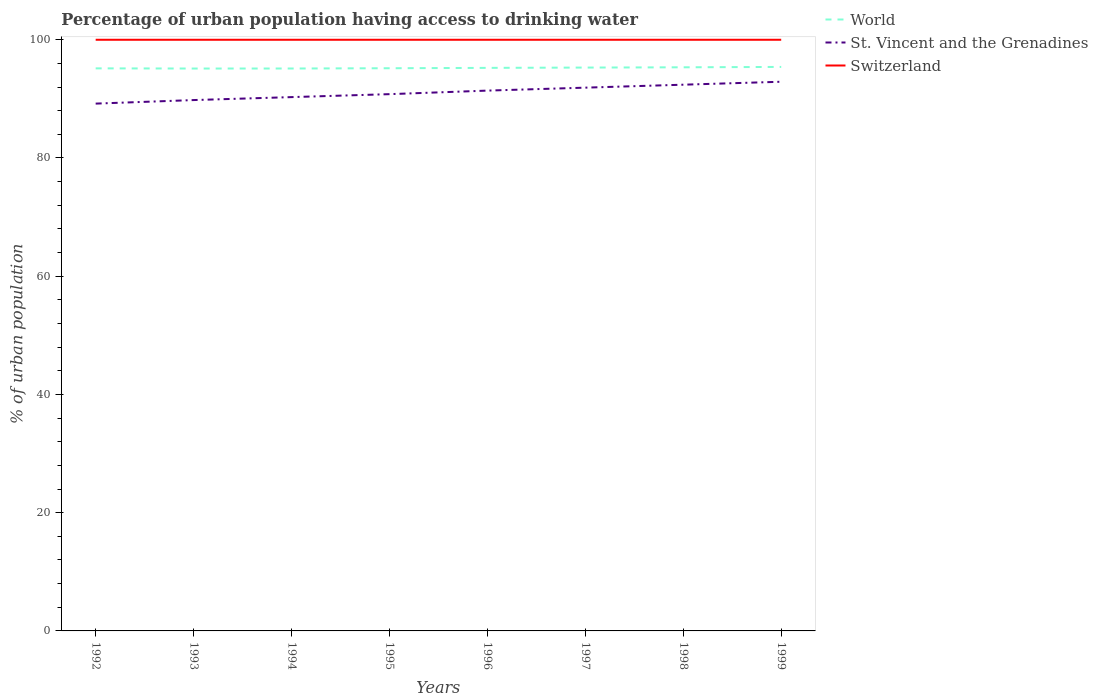How many different coloured lines are there?
Your response must be concise. 3. Is the number of lines equal to the number of legend labels?
Offer a very short reply. Yes. Across all years, what is the maximum percentage of urban population having access to drinking water in World?
Give a very brief answer. 95.13. What is the difference between the highest and the second highest percentage of urban population having access to drinking water in Switzerland?
Provide a short and direct response. 0. What is the difference between the highest and the lowest percentage of urban population having access to drinking water in St. Vincent and the Grenadines?
Ensure brevity in your answer.  4. How many lines are there?
Provide a succinct answer. 3. How many years are there in the graph?
Offer a very short reply. 8. What is the difference between two consecutive major ticks on the Y-axis?
Give a very brief answer. 20. Are the values on the major ticks of Y-axis written in scientific E-notation?
Make the answer very short. No. Does the graph contain any zero values?
Give a very brief answer. No. Does the graph contain grids?
Your response must be concise. No. How are the legend labels stacked?
Offer a terse response. Vertical. What is the title of the graph?
Offer a terse response. Percentage of urban population having access to drinking water. Does "Liberia" appear as one of the legend labels in the graph?
Give a very brief answer. No. What is the label or title of the X-axis?
Ensure brevity in your answer.  Years. What is the label or title of the Y-axis?
Offer a very short reply. % of urban population. What is the % of urban population of World in 1992?
Offer a terse response. 95.16. What is the % of urban population in St. Vincent and the Grenadines in 1992?
Your answer should be compact. 89.2. What is the % of urban population of World in 1993?
Keep it short and to the point. 95.13. What is the % of urban population of St. Vincent and the Grenadines in 1993?
Keep it short and to the point. 89.8. What is the % of urban population of Switzerland in 1993?
Provide a succinct answer. 100. What is the % of urban population of World in 1994?
Provide a short and direct response. 95.14. What is the % of urban population in St. Vincent and the Grenadines in 1994?
Ensure brevity in your answer.  90.3. What is the % of urban population of Switzerland in 1994?
Make the answer very short. 100. What is the % of urban population of World in 1995?
Offer a terse response. 95.18. What is the % of urban population of St. Vincent and the Grenadines in 1995?
Your response must be concise. 90.8. What is the % of urban population in World in 1996?
Provide a succinct answer. 95.25. What is the % of urban population of St. Vincent and the Grenadines in 1996?
Give a very brief answer. 91.4. What is the % of urban population of Switzerland in 1996?
Provide a succinct answer. 100. What is the % of urban population in World in 1997?
Your answer should be compact. 95.3. What is the % of urban population in St. Vincent and the Grenadines in 1997?
Your response must be concise. 91.9. What is the % of urban population in World in 1998?
Your answer should be very brief. 95.34. What is the % of urban population of St. Vincent and the Grenadines in 1998?
Make the answer very short. 92.4. What is the % of urban population of Switzerland in 1998?
Give a very brief answer. 100. What is the % of urban population in World in 1999?
Make the answer very short. 95.41. What is the % of urban population in St. Vincent and the Grenadines in 1999?
Offer a terse response. 92.9. What is the % of urban population of Switzerland in 1999?
Offer a terse response. 100. Across all years, what is the maximum % of urban population in World?
Ensure brevity in your answer.  95.41. Across all years, what is the maximum % of urban population of St. Vincent and the Grenadines?
Your answer should be very brief. 92.9. Across all years, what is the minimum % of urban population of World?
Your response must be concise. 95.13. Across all years, what is the minimum % of urban population of St. Vincent and the Grenadines?
Make the answer very short. 89.2. What is the total % of urban population of World in the graph?
Keep it short and to the point. 761.91. What is the total % of urban population in St. Vincent and the Grenadines in the graph?
Offer a terse response. 728.7. What is the total % of urban population in Switzerland in the graph?
Your response must be concise. 800. What is the difference between the % of urban population in World in 1992 and that in 1993?
Offer a very short reply. 0.03. What is the difference between the % of urban population of St. Vincent and the Grenadines in 1992 and that in 1993?
Offer a very short reply. -0.6. What is the difference between the % of urban population in Switzerland in 1992 and that in 1993?
Provide a short and direct response. 0. What is the difference between the % of urban population in World in 1992 and that in 1994?
Provide a succinct answer. 0.02. What is the difference between the % of urban population of Switzerland in 1992 and that in 1994?
Keep it short and to the point. 0. What is the difference between the % of urban population of World in 1992 and that in 1995?
Your answer should be very brief. -0.02. What is the difference between the % of urban population in World in 1992 and that in 1996?
Give a very brief answer. -0.08. What is the difference between the % of urban population of Switzerland in 1992 and that in 1996?
Your response must be concise. 0. What is the difference between the % of urban population in World in 1992 and that in 1997?
Your response must be concise. -0.13. What is the difference between the % of urban population in St. Vincent and the Grenadines in 1992 and that in 1997?
Give a very brief answer. -2.7. What is the difference between the % of urban population of World in 1992 and that in 1998?
Your answer should be compact. -0.18. What is the difference between the % of urban population of World in 1992 and that in 1999?
Give a very brief answer. -0.24. What is the difference between the % of urban population of St. Vincent and the Grenadines in 1992 and that in 1999?
Provide a short and direct response. -3.7. What is the difference between the % of urban population of World in 1993 and that in 1994?
Give a very brief answer. -0.01. What is the difference between the % of urban population in St. Vincent and the Grenadines in 1993 and that in 1994?
Provide a succinct answer. -0.5. What is the difference between the % of urban population of Switzerland in 1993 and that in 1994?
Keep it short and to the point. 0. What is the difference between the % of urban population in St. Vincent and the Grenadines in 1993 and that in 1995?
Provide a succinct answer. -1. What is the difference between the % of urban population of Switzerland in 1993 and that in 1995?
Keep it short and to the point. 0. What is the difference between the % of urban population in World in 1993 and that in 1996?
Your response must be concise. -0.11. What is the difference between the % of urban population of Switzerland in 1993 and that in 1996?
Offer a terse response. 0. What is the difference between the % of urban population in World in 1993 and that in 1997?
Your answer should be very brief. -0.16. What is the difference between the % of urban population of Switzerland in 1993 and that in 1997?
Offer a terse response. 0. What is the difference between the % of urban population in World in 1993 and that in 1998?
Offer a very short reply. -0.21. What is the difference between the % of urban population of World in 1993 and that in 1999?
Offer a terse response. -0.27. What is the difference between the % of urban population in World in 1994 and that in 1995?
Give a very brief answer. -0.04. What is the difference between the % of urban population in Switzerland in 1994 and that in 1995?
Make the answer very short. 0. What is the difference between the % of urban population in World in 1994 and that in 1996?
Keep it short and to the point. -0.11. What is the difference between the % of urban population of World in 1994 and that in 1997?
Provide a short and direct response. -0.16. What is the difference between the % of urban population of World in 1994 and that in 1998?
Your answer should be compact. -0.2. What is the difference between the % of urban population of St. Vincent and the Grenadines in 1994 and that in 1998?
Ensure brevity in your answer.  -2.1. What is the difference between the % of urban population in World in 1994 and that in 1999?
Provide a short and direct response. -0.27. What is the difference between the % of urban population in World in 1995 and that in 1996?
Your response must be concise. -0.06. What is the difference between the % of urban population in Switzerland in 1995 and that in 1996?
Your answer should be very brief. 0. What is the difference between the % of urban population in World in 1995 and that in 1997?
Your answer should be compact. -0.11. What is the difference between the % of urban population in Switzerland in 1995 and that in 1997?
Offer a very short reply. 0. What is the difference between the % of urban population of World in 1995 and that in 1998?
Make the answer very short. -0.16. What is the difference between the % of urban population of St. Vincent and the Grenadines in 1995 and that in 1998?
Keep it short and to the point. -1.6. What is the difference between the % of urban population in Switzerland in 1995 and that in 1998?
Ensure brevity in your answer.  0. What is the difference between the % of urban population of World in 1995 and that in 1999?
Your answer should be compact. -0.22. What is the difference between the % of urban population in World in 1996 and that in 1997?
Ensure brevity in your answer.  -0.05. What is the difference between the % of urban population of World in 1996 and that in 1998?
Keep it short and to the point. -0.1. What is the difference between the % of urban population in St. Vincent and the Grenadines in 1996 and that in 1998?
Your response must be concise. -1. What is the difference between the % of urban population of World in 1996 and that in 1999?
Your answer should be compact. -0.16. What is the difference between the % of urban population in World in 1997 and that in 1998?
Provide a succinct answer. -0.04. What is the difference between the % of urban population in World in 1997 and that in 1999?
Provide a succinct answer. -0.11. What is the difference between the % of urban population in St. Vincent and the Grenadines in 1997 and that in 1999?
Give a very brief answer. -1. What is the difference between the % of urban population in World in 1998 and that in 1999?
Provide a succinct answer. -0.06. What is the difference between the % of urban population in St. Vincent and the Grenadines in 1998 and that in 1999?
Your response must be concise. -0.5. What is the difference between the % of urban population in World in 1992 and the % of urban population in St. Vincent and the Grenadines in 1993?
Offer a terse response. 5.36. What is the difference between the % of urban population in World in 1992 and the % of urban population in Switzerland in 1993?
Offer a terse response. -4.84. What is the difference between the % of urban population in St. Vincent and the Grenadines in 1992 and the % of urban population in Switzerland in 1993?
Make the answer very short. -10.8. What is the difference between the % of urban population in World in 1992 and the % of urban population in St. Vincent and the Grenadines in 1994?
Your answer should be very brief. 4.86. What is the difference between the % of urban population of World in 1992 and the % of urban population of Switzerland in 1994?
Provide a short and direct response. -4.84. What is the difference between the % of urban population of World in 1992 and the % of urban population of St. Vincent and the Grenadines in 1995?
Offer a very short reply. 4.36. What is the difference between the % of urban population in World in 1992 and the % of urban population in Switzerland in 1995?
Offer a terse response. -4.84. What is the difference between the % of urban population in St. Vincent and the Grenadines in 1992 and the % of urban population in Switzerland in 1995?
Your answer should be compact. -10.8. What is the difference between the % of urban population of World in 1992 and the % of urban population of St. Vincent and the Grenadines in 1996?
Your response must be concise. 3.76. What is the difference between the % of urban population in World in 1992 and the % of urban population in Switzerland in 1996?
Your response must be concise. -4.84. What is the difference between the % of urban population of St. Vincent and the Grenadines in 1992 and the % of urban population of Switzerland in 1996?
Offer a terse response. -10.8. What is the difference between the % of urban population in World in 1992 and the % of urban population in St. Vincent and the Grenadines in 1997?
Offer a very short reply. 3.26. What is the difference between the % of urban population of World in 1992 and the % of urban population of Switzerland in 1997?
Your response must be concise. -4.84. What is the difference between the % of urban population in World in 1992 and the % of urban population in St. Vincent and the Grenadines in 1998?
Provide a short and direct response. 2.76. What is the difference between the % of urban population of World in 1992 and the % of urban population of Switzerland in 1998?
Provide a succinct answer. -4.84. What is the difference between the % of urban population of St. Vincent and the Grenadines in 1992 and the % of urban population of Switzerland in 1998?
Provide a short and direct response. -10.8. What is the difference between the % of urban population in World in 1992 and the % of urban population in St. Vincent and the Grenadines in 1999?
Offer a terse response. 2.26. What is the difference between the % of urban population in World in 1992 and the % of urban population in Switzerland in 1999?
Your response must be concise. -4.84. What is the difference between the % of urban population of World in 1993 and the % of urban population of St. Vincent and the Grenadines in 1994?
Keep it short and to the point. 4.83. What is the difference between the % of urban population of World in 1993 and the % of urban population of Switzerland in 1994?
Your answer should be compact. -4.87. What is the difference between the % of urban population of World in 1993 and the % of urban population of St. Vincent and the Grenadines in 1995?
Provide a succinct answer. 4.33. What is the difference between the % of urban population in World in 1993 and the % of urban population in Switzerland in 1995?
Provide a short and direct response. -4.87. What is the difference between the % of urban population of St. Vincent and the Grenadines in 1993 and the % of urban population of Switzerland in 1995?
Provide a succinct answer. -10.2. What is the difference between the % of urban population in World in 1993 and the % of urban population in St. Vincent and the Grenadines in 1996?
Your answer should be very brief. 3.73. What is the difference between the % of urban population in World in 1993 and the % of urban population in Switzerland in 1996?
Offer a terse response. -4.87. What is the difference between the % of urban population of World in 1993 and the % of urban population of St. Vincent and the Grenadines in 1997?
Offer a very short reply. 3.23. What is the difference between the % of urban population in World in 1993 and the % of urban population in Switzerland in 1997?
Offer a very short reply. -4.87. What is the difference between the % of urban population of World in 1993 and the % of urban population of St. Vincent and the Grenadines in 1998?
Your answer should be compact. 2.73. What is the difference between the % of urban population in World in 1993 and the % of urban population in Switzerland in 1998?
Offer a terse response. -4.87. What is the difference between the % of urban population in World in 1993 and the % of urban population in St. Vincent and the Grenadines in 1999?
Your answer should be very brief. 2.23. What is the difference between the % of urban population in World in 1993 and the % of urban population in Switzerland in 1999?
Your response must be concise. -4.87. What is the difference between the % of urban population of World in 1994 and the % of urban population of St. Vincent and the Grenadines in 1995?
Your answer should be very brief. 4.34. What is the difference between the % of urban population of World in 1994 and the % of urban population of Switzerland in 1995?
Your answer should be compact. -4.86. What is the difference between the % of urban population of St. Vincent and the Grenadines in 1994 and the % of urban population of Switzerland in 1995?
Your response must be concise. -9.7. What is the difference between the % of urban population in World in 1994 and the % of urban population in St. Vincent and the Grenadines in 1996?
Your response must be concise. 3.74. What is the difference between the % of urban population of World in 1994 and the % of urban population of Switzerland in 1996?
Offer a very short reply. -4.86. What is the difference between the % of urban population in St. Vincent and the Grenadines in 1994 and the % of urban population in Switzerland in 1996?
Provide a short and direct response. -9.7. What is the difference between the % of urban population of World in 1994 and the % of urban population of St. Vincent and the Grenadines in 1997?
Give a very brief answer. 3.24. What is the difference between the % of urban population of World in 1994 and the % of urban population of Switzerland in 1997?
Provide a succinct answer. -4.86. What is the difference between the % of urban population in St. Vincent and the Grenadines in 1994 and the % of urban population in Switzerland in 1997?
Provide a short and direct response. -9.7. What is the difference between the % of urban population of World in 1994 and the % of urban population of St. Vincent and the Grenadines in 1998?
Provide a short and direct response. 2.74. What is the difference between the % of urban population in World in 1994 and the % of urban population in Switzerland in 1998?
Offer a terse response. -4.86. What is the difference between the % of urban population of World in 1994 and the % of urban population of St. Vincent and the Grenadines in 1999?
Make the answer very short. 2.24. What is the difference between the % of urban population of World in 1994 and the % of urban population of Switzerland in 1999?
Offer a terse response. -4.86. What is the difference between the % of urban population in St. Vincent and the Grenadines in 1994 and the % of urban population in Switzerland in 1999?
Make the answer very short. -9.7. What is the difference between the % of urban population in World in 1995 and the % of urban population in St. Vincent and the Grenadines in 1996?
Make the answer very short. 3.78. What is the difference between the % of urban population of World in 1995 and the % of urban population of Switzerland in 1996?
Your answer should be compact. -4.82. What is the difference between the % of urban population in St. Vincent and the Grenadines in 1995 and the % of urban population in Switzerland in 1996?
Provide a short and direct response. -9.2. What is the difference between the % of urban population in World in 1995 and the % of urban population in St. Vincent and the Grenadines in 1997?
Give a very brief answer. 3.28. What is the difference between the % of urban population in World in 1995 and the % of urban population in Switzerland in 1997?
Offer a very short reply. -4.82. What is the difference between the % of urban population in World in 1995 and the % of urban population in St. Vincent and the Grenadines in 1998?
Your answer should be compact. 2.78. What is the difference between the % of urban population in World in 1995 and the % of urban population in Switzerland in 1998?
Provide a succinct answer. -4.82. What is the difference between the % of urban population in St. Vincent and the Grenadines in 1995 and the % of urban population in Switzerland in 1998?
Offer a very short reply. -9.2. What is the difference between the % of urban population in World in 1995 and the % of urban population in St. Vincent and the Grenadines in 1999?
Your answer should be compact. 2.28. What is the difference between the % of urban population of World in 1995 and the % of urban population of Switzerland in 1999?
Keep it short and to the point. -4.82. What is the difference between the % of urban population of St. Vincent and the Grenadines in 1995 and the % of urban population of Switzerland in 1999?
Offer a terse response. -9.2. What is the difference between the % of urban population of World in 1996 and the % of urban population of St. Vincent and the Grenadines in 1997?
Give a very brief answer. 3.35. What is the difference between the % of urban population in World in 1996 and the % of urban population in Switzerland in 1997?
Your answer should be compact. -4.75. What is the difference between the % of urban population of St. Vincent and the Grenadines in 1996 and the % of urban population of Switzerland in 1997?
Provide a succinct answer. -8.6. What is the difference between the % of urban population of World in 1996 and the % of urban population of St. Vincent and the Grenadines in 1998?
Offer a terse response. 2.85. What is the difference between the % of urban population of World in 1996 and the % of urban population of Switzerland in 1998?
Provide a succinct answer. -4.75. What is the difference between the % of urban population in World in 1996 and the % of urban population in St. Vincent and the Grenadines in 1999?
Make the answer very short. 2.35. What is the difference between the % of urban population of World in 1996 and the % of urban population of Switzerland in 1999?
Ensure brevity in your answer.  -4.75. What is the difference between the % of urban population in World in 1997 and the % of urban population in St. Vincent and the Grenadines in 1998?
Your answer should be compact. 2.9. What is the difference between the % of urban population in World in 1997 and the % of urban population in Switzerland in 1998?
Provide a succinct answer. -4.7. What is the difference between the % of urban population in St. Vincent and the Grenadines in 1997 and the % of urban population in Switzerland in 1998?
Give a very brief answer. -8.1. What is the difference between the % of urban population of World in 1997 and the % of urban population of St. Vincent and the Grenadines in 1999?
Your answer should be very brief. 2.4. What is the difference between the % of urban population of World in 1997 and the % of urban population of Switzerland in 1999?
Provide a succinct answer. -4.7. What is the difference between the % of urban population in World in 1998 and the % of urban population in St. Vincent and the Grenadines in 1999?
Offer a terse response. 2.44. What is the difference between the % of urban population in World in 1998 and the % of urban population in Switzerland in 1999?
Your answer should be compact. -4.66. What is the difference between the % of urban population in St. Vincent and the Grenadines in 1998 and the % of urban population in Switzerland in 1999?
Ensure brevity in your answer.  -7.6. What is the average % of urban population of World per year?
Keep it short and to the point. 95.24. What is the average % of urban population in St. Vincent and the Grenadines per year?
Keep it short and to the point. 91.09. What is the average % of urban population in Switzerland per year?
Make the answer very short. 100. In the year 1992, what is the difference between the % of urban population in World and % of urban population in St. Vincent and the Grenadines?
Your response must be concise. 5.96. In the year 1992, what is the difference between the % of urban population of World and % of urban population of Switzerland?
Your response must be concise. -4.84. In the year 1992, what is the difference between the % of urban population in St. Vincent and the Grenadines and % of urban population in Switzerland?
Your response must be concise. -10.8. In the year 1993, what is the difference between the % of urban population in World and % of urban population in St. Vincent and the Grenadines?
Your response must be concise. 5.33. In the year 1993, what is the difference between the % of urban population in World and % of urban population in Switzerland?
Ensure brevity in your answer.  -4.87. In the year 1994, what is the difference between the % of urban population in World and % of urban population in St. Vincent and the Grenadines?
Keep it short and to the point. 4.84. In the year 1994, what is the difference between the % of urban population of World and % of urban population of Switzerland?
Offer a terse response. -4.86. In the year 1994, what is the difference between the % of urban population in St. Vincent and the Grenadines and % of urban population in Switzerland?
Your answer should be very brief. -9.7. In the year 1995, what is the difference between the % of urban population in World and % of urban population in St. Vincent and the Grenadines?
Your answer should be compact. 4.38. In the year 1995, what is the difference between the % of urban population in World and % of urban population in Switzerland?
Ensure brevity in your answer.  -4.82. In the year 1995, what is the difference between the % of urban population in St. Vincent and the Grenadines and % of urban population in Switzerland?
Give a very brief answer. -9.2. In the year 1996, what is the difference between the % of urban population of World and % of urban population of St. Vincent and the Grenadines?
Ensure brevity in your answer.  3.85. In the year 1996, what is the difference between the % of urban population of World and % of urban population of Switzerland?
Keep it short and to the point. -4.75. In the year 1997, what is the difference between the % of urban population in World and % of urban population in St. Vincent and the Grenadines?
Give a very brief answer. 3.4. In the year 1997, what is the difference between the % of urban population of World and % of urban population of Switzerland?
Make the answer very short. -4.7. In the year 1997, what is the difference between the % of urban population of St. Vincent and the Grenadines and % of urban population of Switzerland?
Your response must be concise. -8.1. In the year 1998, what is the difference between the % of urban population of World and % of urban population of St. Vincent and the Grenadines?
Your answer should be very brief. 2.94. In the year 1998, what is the difference between the % of urban population of World and % of urban population of Switzerland?
Make the answer very short. -4.66. In the year 1998, what is the difference between the % of urban population of St. Vincent and the Grenadines and % of urban population of Switzerland?
Offer a terse response. -7.6. In the year 1999, what is the difference between the % of urban population in World and % of urban population in St. Vincent and the Grenadines?
Give a very brief answer. 2.51. In the year 1999, what is the difference between the % of urban population of World and % of urban population of Switzerland?
Your response must be concise. -4.59. In the year 1999, what is the difference between the % of urban population in St. Vincent and the Grenadines and % of urban population in Switzerland?
Ensure brevity in your answer.  -7.1. What is the ratio of the % of urban population of World in 1992 to that in 1993?
Your answer should be compact. 1. What is the ratio of the % of urban population in Switzerland in 1992 to that in 1993?
Keep it short and to the point. 1. What is the ratio of the % of urban population of Switzerland in 1992 to that in 1994?
Provide a short and direct response. 1. What is the ratio of the % of urban population of St. Vincent and the Grenadines in 1992 to that in 1995?
Give a very brief answer. 0.98. What is the ratio of the % of urban population in St. Vincent and the Grenadines in 1992 to that in 1996?
Your answer should be very brief. 0.98. What is the ratio of the % of urban population of World in 1992 to that in 1997?
Your response must be concise. 1. What is the ratio of the % of urban population in St. Vincent and the Grenadines in 1992 to that in 1997?
Provide a succinct answer. 0.97. What is the ratio of the % of urban population in World in 1992 to that in 1998?
Provide a succinct answer. 1. What is the ratio of the % of urban population in St. Vincent and the Grenadines in 1992 to that in 1998?
Provide a short and direct response. 0.97. What is the ratio of the % of urban population in Switzerland in 1992 to that in 1998?
Keep it short and to the point. 1. What is the ratio of the % of urban population of St. Vincent and the Grenadines in 1992 to that in 1999?
Ensure brevity in your answer.  0.96. What is the ratio of the % of urban population of World in 1993 to that in 1994?
Provide a short and direct response. 1. What is the ratio of the % of urban population in World in 1993 to that in 1995?
Keep it short and to the point. 1. What is the ratio of the % of urban population in Switzerland in 1993 to that in 1995?
Your answer should be very brief. 1. What is the ratio of the % of urban population of St. Vincent and the Grenadines in 1993 to that in 1996?
Offer a terse response. 0.98. What is the ratio of the % of urban population of Switzerland in 1993 to that in 1996?
Ensure brevity in your answer.  1. What is the ratio of the % of urban population in St. Vincent and the Grenadines in 1993 to that in 1997?
Ensure brevity in your answer.  0.98. What is the ratio of the % of urban population of St. Vincent and the Grenadines in 1993 to that in 1998?
Keep it short and to the point. 0.97. What is the ratio of the % of urban population in St. Vincent and the Grenadines in 1993 to that in 1999?
Offer a terse response. 0.97. What is the ratio of the % of urban population in World in 1994 to that in 1995?
Provide a short and direct response. 1. What is the ratio of the % of urban population of St. Vincent and the Grenadines in 1994 to that in 1995?
Your answer should be compact. 0.99. What is the ratio of the % of urban population of Switzerland in 1994 to that in 1995?
Offer a terse response. 1. What is the ratio of the % of urban population in World in 1994 to that in 1996?
Your answer should be very brief. 1. What is the ratio of the % of urban population of St. Vincent and the Grenadines in 1994 to that in 1996?
Your response must be concise. 0.99. What is the ratio of the % of urban population of Switzerland in 1994 to that in 1996?
Give a very brief answer. 1. What is the ratio of the % of urban population in World in 1994 to that in 1997?
Give a very brief answer. 1. What is the ratio of the % of urban population in St. Vincent and the Grenadines in 1994 to that in 1997?
Provide a succinct answer. 0.98. What is the ratio of the % of urban population in World in 1994 to that in 1998?
Your answer should be compact. 1. What is the ratio of the % of urban population in St. Vincent and the Grenadines in 1994 to that in 1998?
Provide a short and direct response. 0.98. What is the ratio of the % of urban population in Switzerland in 1994 to that in 1998?
Your answer should be very brief. 1. What is the ratio of the % of urban population in World in 1994 to that in 1999?
Offer a very short reply. 1. What is the ratio of the % of urban population in St. Vincent and the Grenadines in 1994 to that in 1999?
Your answer should be very brief. 0.97. What is the ratio of the % of urban population in World in 1995 to that in 1996?
Keep it short and to the point. 1. What is the ratio of the % of urban population of St. Vincent and the Grenadines in 1995 to that in 1996?
Provide a short and direct response. 0.99. What is the ratio of the % of urban population in Switzerland in 1995 to that in 1996?
Offer a terse response. 1. What is the ratio of the % of urban population in St. Vincent and the Grenadines in 1995 to that in 1998?
Give a very brief answer. 0.98. What is the ratio of the % of urban population in St. Vincent and the Grenadines in 1995 to that in 1999?
Your answer should be very brief. 0.98. What is the ratio of the % of urban population of Switzerland in 1995 to that in 1999?
Offer a very short reply. 1. What is the ratio of the % of urban population of World in 1996 to that in 1997?
Ensure brevity in your answer.  1. What is the ratio of the % of urban population of St. Vincent and the Grenadines in 1996 to that in 1997?
Ensure brevity in your answer.  0.99. What is the ratio of the % of urban population in Switzerland in 1996 to that in 1997?
Your answer should be very brief. 1. What is the ratio of the % of urban population in World in 1996 to that in 1998?
Provide a short and direct response. 1. What is the ratio of the % of urban population of St. Vincent and the Grenadines in 1996 to that in 1998?
Provide a short and direct response. 0.99. What is the ratio of the % of urban population of Switzerland in 1996 to that in 1998?
Keep it short and to the point. 1. What is the ratio of the % of urban population in St. Vincent and the Grenadines in 1996 to that in 1999?
Make the answer very short. 0.98. What is the ratio of the % of urban population in Switzerland in 1996 to that in 1999?
Ensure brevity in your answer.  1. What is the ratio of the % of urban population of World in 1997 to that in 1998?
Give a very brief answer. 1. What is the ratio of the % of urban population of Switzerland in 1997 to that in 1998?
Provide a short and direct response. 1. What is the ratio of the % of urban population in World in 1997 to that in 1999?
Ensure brevity in your answer.  1. What is the difference between the highest and the second highest % of urban population of World?
Keep it short and to the point. 0.06. What is the difference between the highest and the second highest % of urban population of St. Vincent and the Grenadines?
Provide a short and direct response. 0.5. What is the difference between the highest and the lowest % of urban population in World?
Provide a short and direct response. 0.27. What is the difference between the highest and the lowest % of urban population in Switzerland?
Ensure brevity in your answer.  0. 